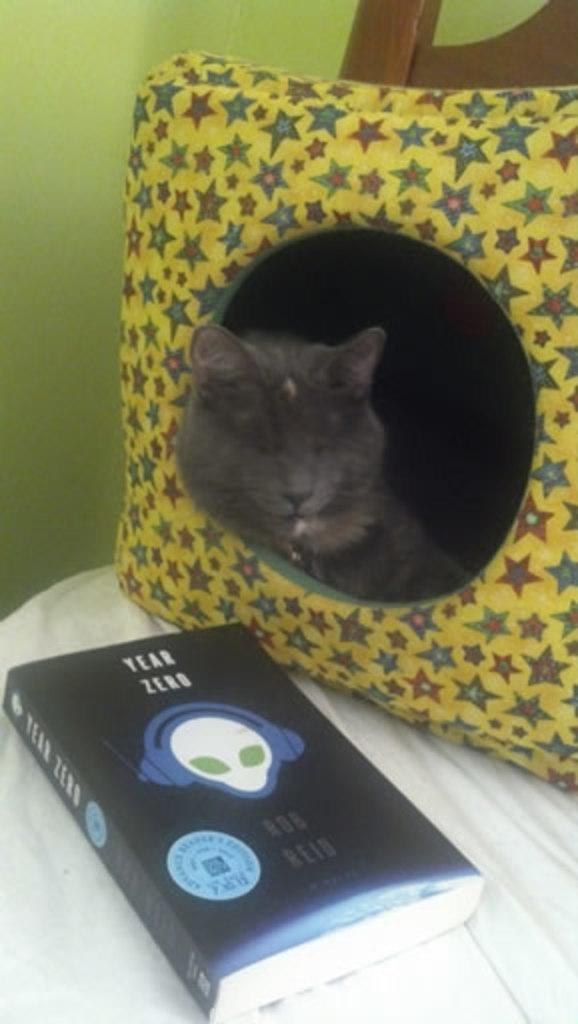What type of animal can be seen in the image? There is a cat in the image. What is the cat doing in the image? The cat is sleeping on a pillow. What other object is present in the image besides the cat? There is a book in the image. Where is the book located in the image? The book is kept on a chair. How does the cat set up the tent in the image? There is no tent present in the image, and the cat is not shown setting up anything. 